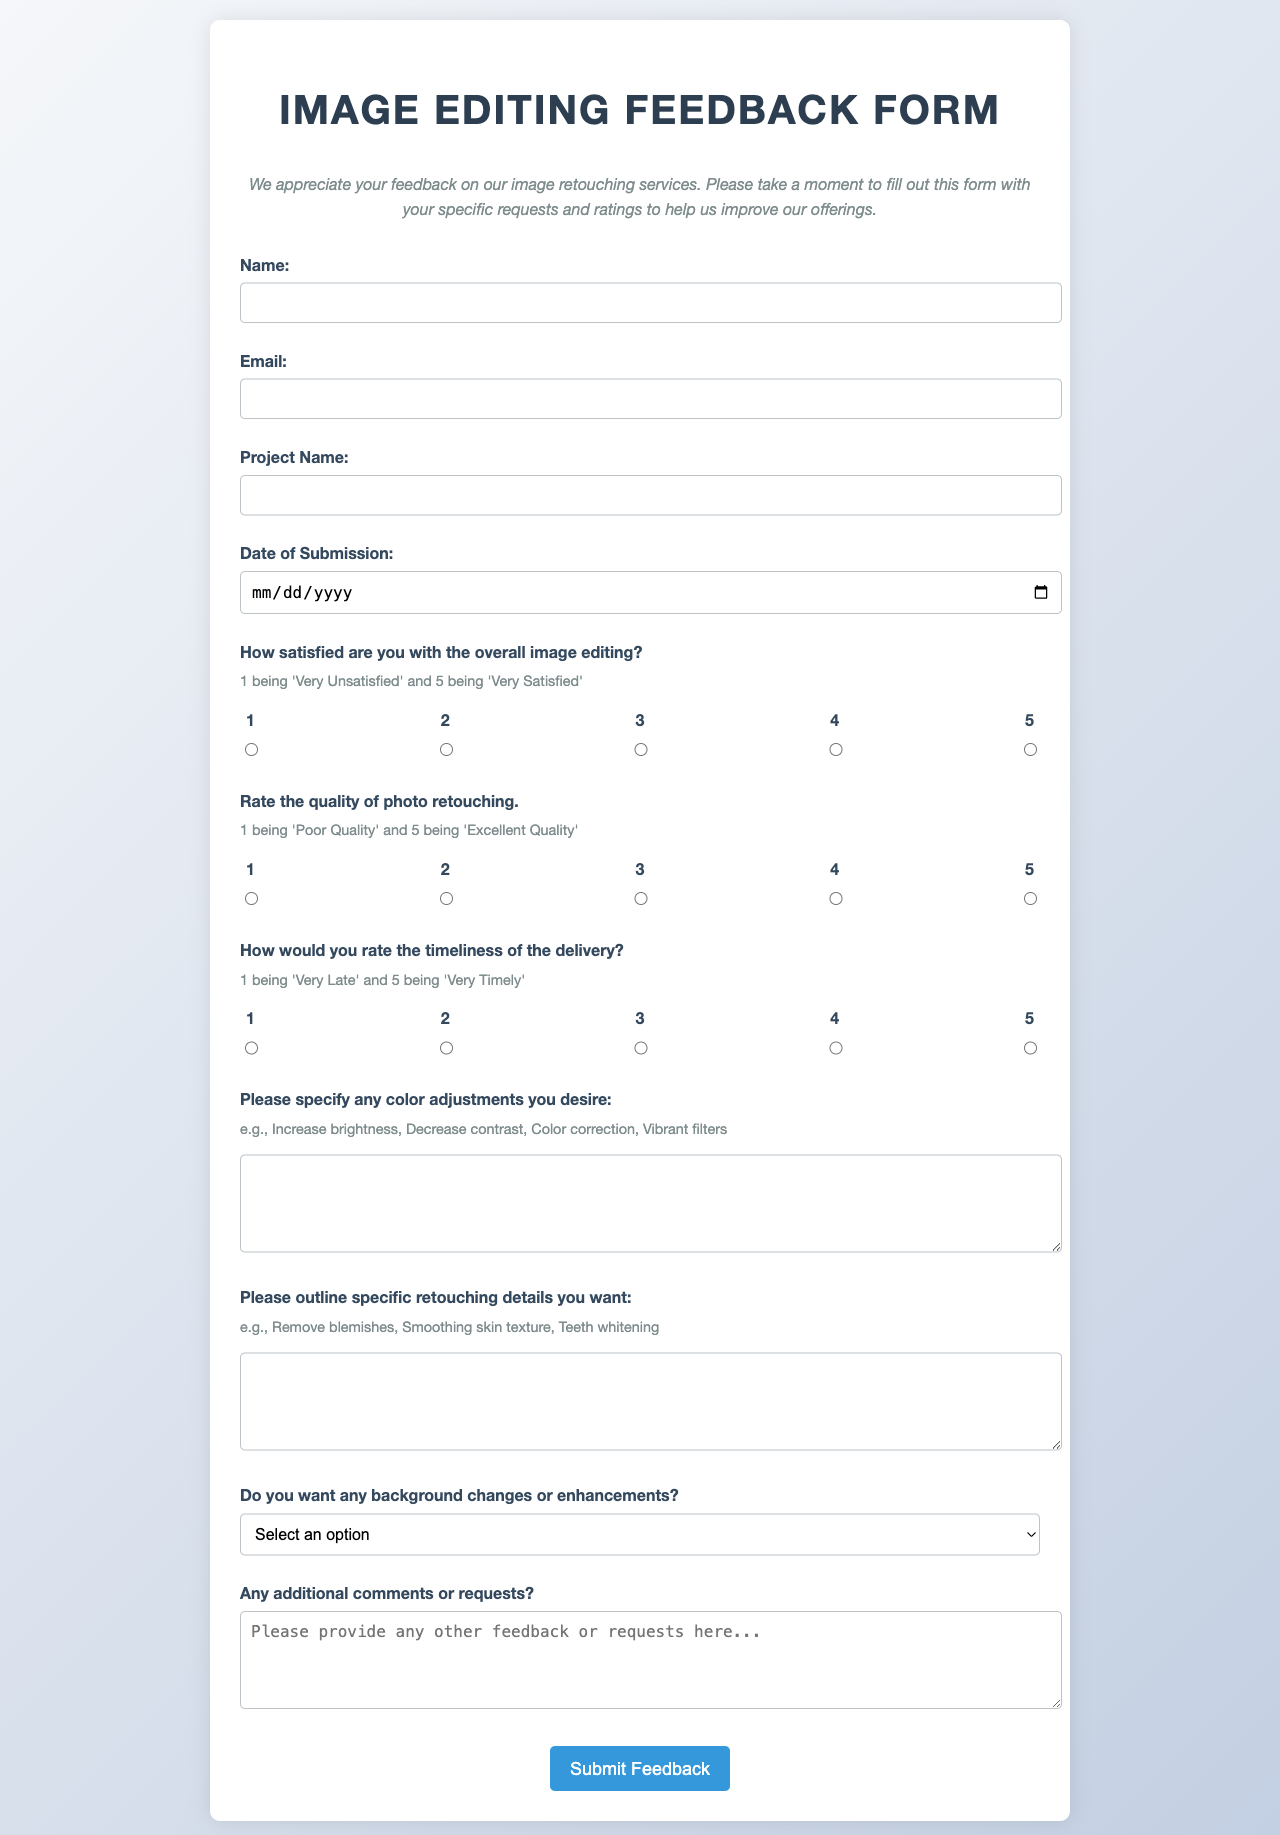What is the title of the form? The title is prominently displayed at the top of the document, indicating the main purpose of the form.
Answer: Image Editing Feedback Form What is the required information for the "Name" field? This field is indicated as required in the form, meaning the respondent must provide their name.
Answer: Name What type of feedback is asked regarding overall image editing satisfaction? The form explicitly asks for a satisfaction rating, which is rated on a scale of 1 to 5.
Answer: Overall satisfaction What is the highest rating one can give for the quality of photo retouching? The form allows respondents to rate on a 1 to 5 scale, where 5 represents the highest quality of edits.
Answer: 5 What specific color adjustments can respondents specify in the form? The form encourages users to describe various color adjustments, providing examples for clarity.
Answer: e.g., Increase brightness How many rows is the text area for additional comments? The form specifies the dimensions of certain text areas, outlining how many lines of text can be entered.
Answer: 4 What is one option available for background changes? The dropdown menu provides specific options related to enhancements for the background in an image.
Answer: Replace background What is the purpose of the "Additional comments" section? This section allows for any further feedback or requests that are not covered by the previous questions.
Answer: Request feedback 